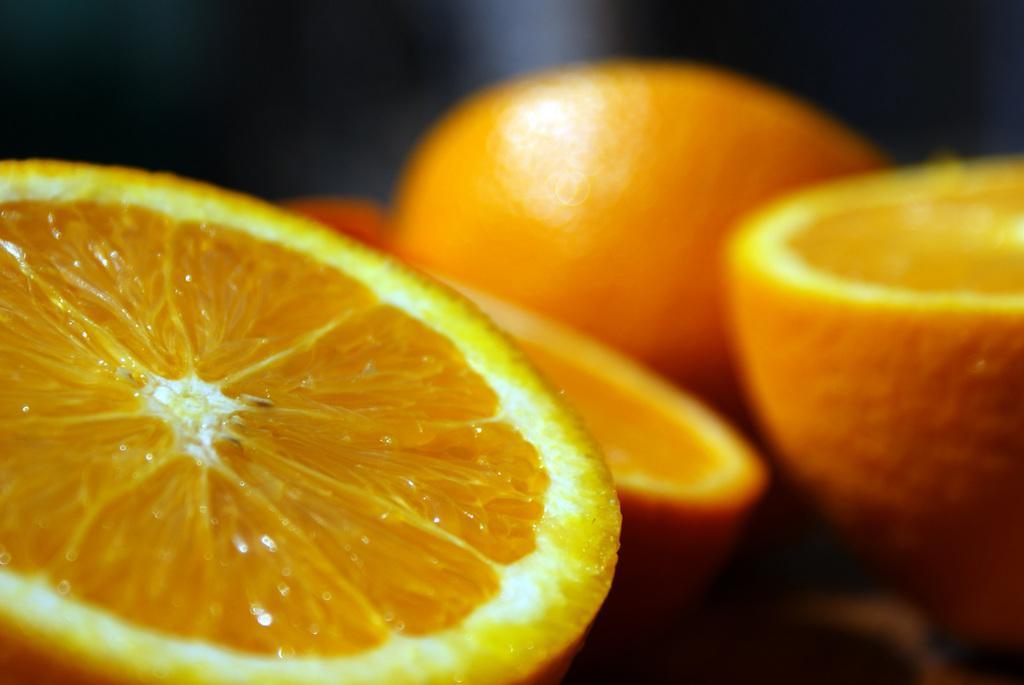Describe this image in one or two sentences. In this image we can see that there are orange pieces. The orange is cut into two pieces. 